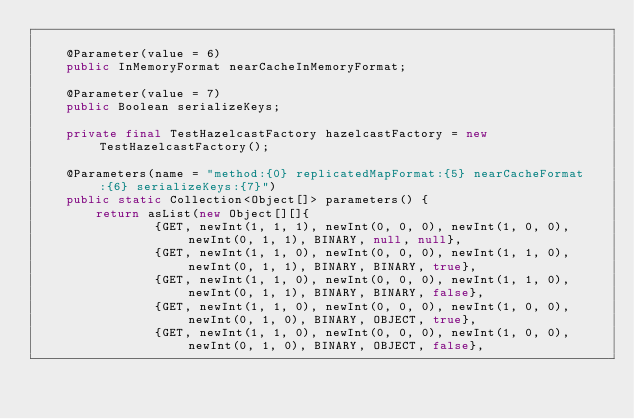Convert code to text. <code><loc_0><loc_0><loc_500><loc_500><_Java_>
    @Parameter(value = 6)
    public InMemoryFormat nearCacheInMemoryFormat;

    @Parameter(value = 7)
    public Boolean serializeKeys;

    private final TestHazelcastFactory hazelcastFactory = new TestHazelcastFactory();

    @Parameters(name = "method:{0} replicatedMapFormat:{5} nearCacheFormat:{6} serializeKeys:{7}")
    public static Collection<Object[]> parameters() {
        return asList(new Object[][]{
                {GET, newInt(1, 1, 1), newInt(0, 0, 0), newInt(1, 0, 0), newInt(0, 1, 1), BINARY, null, null},
                {GET, newInt(1, 1, 0), newInt(0, 0, 0), newInt(1, 1, 0), newInt(0, 1, 1), BINARY, BINARY, true},
                {GET, newInt(1, 1, 0), newInt(0, 0, 0), newInt(1, 1, 0), newInt(0, 1, 1), BINARY, BINARY, false},
                {GET, newInt(1, 1, 0), newInt(0, 0, 0), newInt(1, 0, 0), newInt(0, 1, 0), BINARY, OBJECT, true},
                {GET, newInt(1, 1, 0), newInt(0, 0, 0), newInt(1, 0, 0), newInt(0, 1, 0), BINARY, OBJECT, false},
</code> 